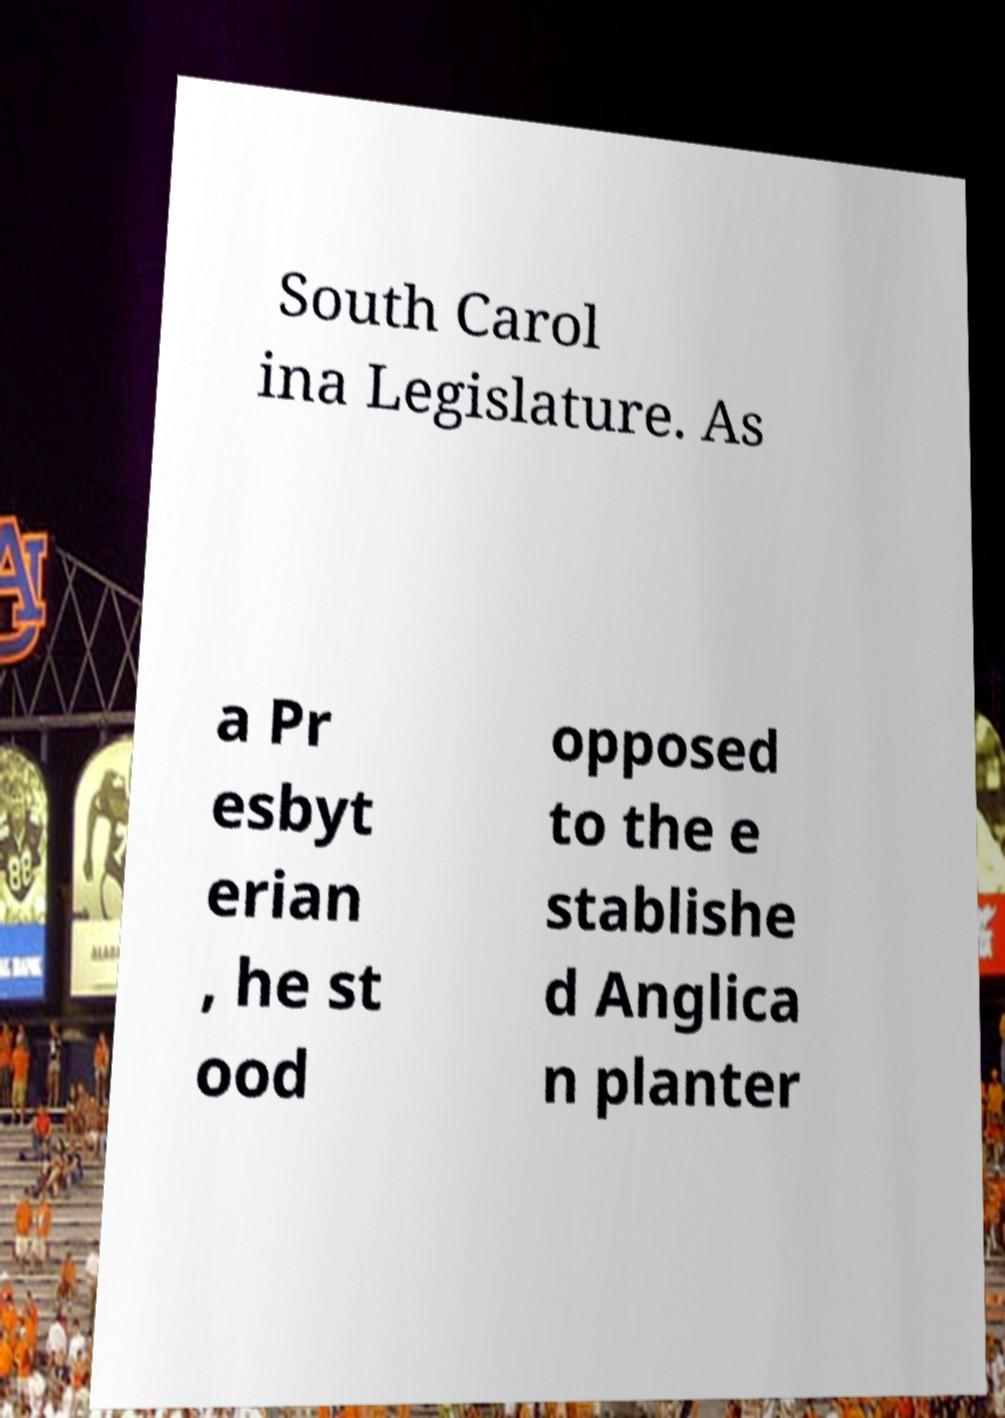Could you extract and type out the text from this image? South Carol ina Legislature. As a Pr esbyt erian , he st ood opposed to the e stablishe d Anglica n planter 